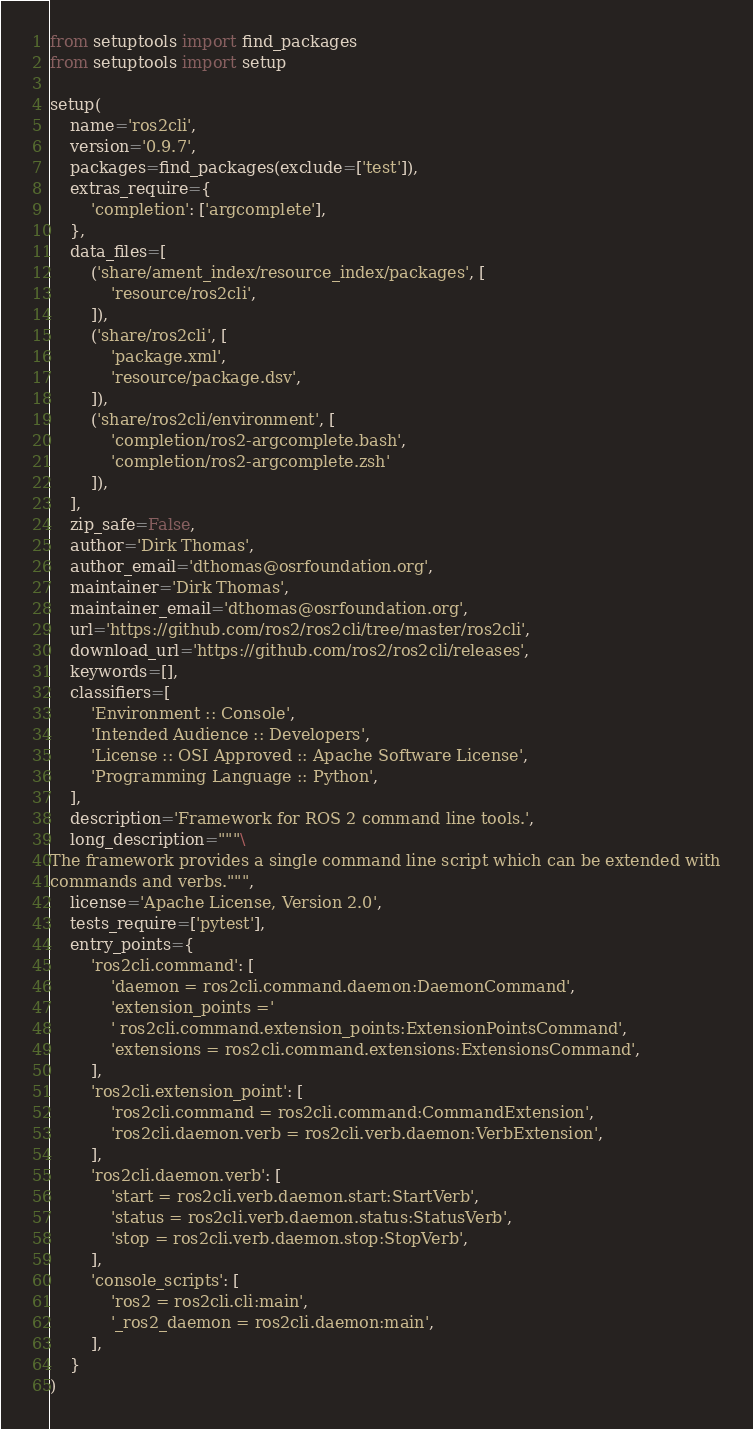Convert code to text. <code><loc_0><loc_0><loc_500><loc_500><_Python_>from setuptools import find_packages
from setuptools import setup

setup(
    name='ros2cli',
    version='0.9.7',
    packages=find_packages(exclude=['test']),
    extras_require={
        'completion': ['argcomplete'],
    },
    data_files=[
        ('share/ament_index/resource_index/packages', [
            'resource/ros2cli',
        ]),
        ('share/ros2cli', [
            'package.xml',
            'resource/package.dsv',
        ]),
        ('share/ros2cli/environment', [
            'completion/ros2-argcomplete.bash',
            'completion/ros2-argcomplete.zsh'
        ]),
    ],
    zip_safe=False,
    author='Dirk Thomas',
    author_email='dthomas@osrfoundation.org',
    maintainer='Dirk Thomas',
    maintainer_email='dthomas@osrfoundation.org',
    url='https://github.com/ros2/ros2cli/tree/master/ros2cli',
    download_url='https://github.com/ros2/ros2cli/releases',
    keywords=[],
    classifiers=[
        'Environment :: Console',
        'Intended Audience :: Developers',
        'License :: OSI Approved :: Apache Software License',
        'Programming Language :: Python',
    ],
    description='Framework for ROS 2 command line tools.',
    long_description="""\
The framework provides a single command line script which can be extended with
commands and verbs.""",
    license='Apache License, Version 2.0',
    tests_require=['pytest'],
    entry_points={
        'ros2cli.command': [
            'daemon = ros2cli.command.daemon:DaemonCommand',
            'extension_points ='
            ' ros2cli.command.extension_points:ExtensionPointsCommand',
            'extensions = ros2cli.command.extensions:ExtensionsCommand',
        ],
        'ros2cli.extension_point': [
            'ros2cli.command = ros2cli.command:CommandExtension',
            'ros2cli.daemon.verb = ros2cli.verb.daemon:VerbExtension',
        ],
        'ros2cli.daemon.verb': [
            'start = ros2cli.verb.daemon.start:StartVerb',
            'status = ros2cli.verb.daemon.status:StatusVerb',
            'stop = ros2cli.verb.daemon.stop:StopVerb',
        ],
        'console_scripts': [
            'ros2 = ros2cli.cli:main',
            '_ros2_daemon = ros2cli.daemon:main',
        ],
    }
)
</code> 